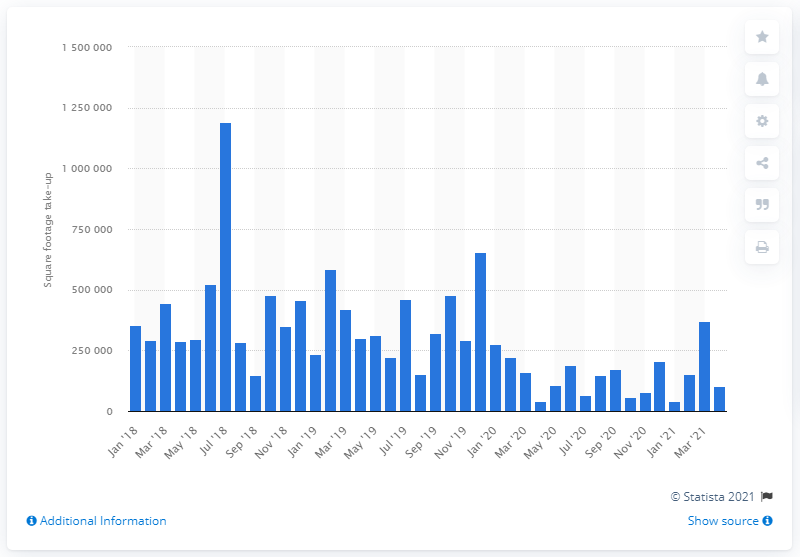Indicate a few pertinent items in this graphic. London West End experienced the highest office take-up in July 2018, with a total of 119,264.8 square feet of space leased. 